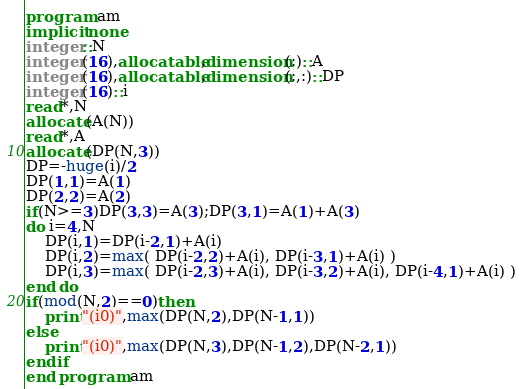Convert code to text. <code><loc_0><loc_0><loc_500><loc_500><_FORTRAN_>program am
implicit none
integer::N
integer(16),allocatable,dimension(:)::A
integer(16),allocatable,dimension(:,:)::DP
integer(16)::i
read*,N
allocate(A(N))
read*,A
allocate(DP(N,3))
DP=-huge(i)/2
DP(1,1)=A(1)
DP(2,2)=A(2)
if(N>=3)DP(3,3)=A(3);DP(3,1)=A(1)+A(3)
do i=4,N
    DP(i,1)=DP(i-2,1)+A(i)
    DP(i,2)=max( DP(i-2,2)+A(i), DP(i-3,1)+A(i) )
    DP(i,3)=max( DP(i-2,3)+A(i), DP(i-3,2)+A(i), DP(i-4,1)+A(i) )
end do
if(mod(N,2)==0)then
    print"(i0)",max(DP(N,2),DP(N-1,1))
else
    print"(i0)",max(DP(N,3),DP(N-1,2),DP(N-2,1))
endif
end program am</code> 